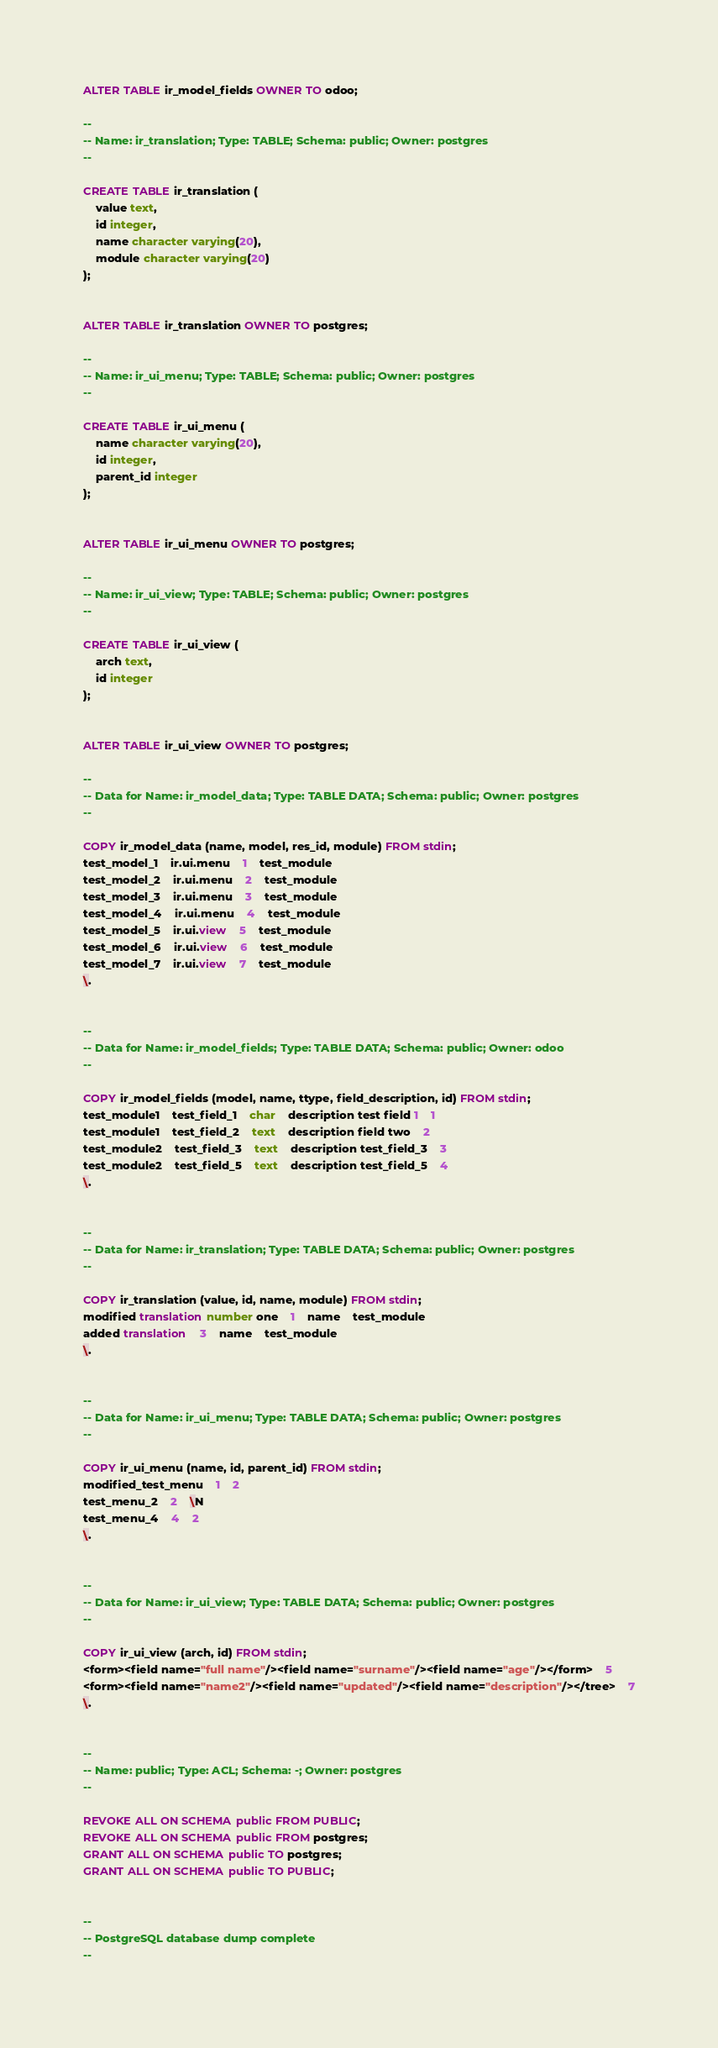Convert code to text. <code><loc_0><loc_0><loc_500><loc_500><_SQL_>
ALTER TABLE ir_model_fields OWNER TO odoo;

--
-- Name: ir_translation; Type: TABLE; Schema: public; Owner: postgres
--

CREATE TABLE ir_translation (
    value text,
    id integer,
    name character varying(20),
    module character varying(20)
);


ALTER TABLE ir_translation OWNER TO postgres;

--
-- Name: ir_ui_menu; Type: TABLE; Schema: public; Owner: postgres
--

CREATE TABLE ir_ui_menu (
    name character varying(20),
    id integer,
    parent_id integer
);


ALTER TABLE ir_ui_menu OWNER TO postgres;

--
-- Name: ir_ui_view; Type: TABLE; Schema: public; Owner: postgres
--

CREATE TABLE ir_ui_view (
    arch text,
    id integer
);


ALTER TABLE ir_ui_view OWNER TO postgres;

--
-- Data for Name: ir_model_data; Type: TABLE DATA; Schema: public; Owner: postgres
--

COPY ir_model_data (name, model, res_id, module) FROM stdin;
test_model_1	ir.ui.menu	1	test_module
test_model_2	ir.ui.menu	2	test_module
test_model_3	ir.ui.menu	3	test_module
test_model_4	ir.ui.menu	4	test_module
test_model_5	ir.ui.view	5	test_module
test_model_6	ir.ui.view	6	test_module
test_model_7	ir.ui.view	7	test_module
\.


--
-- Data for Name: ir_model_fields; Type: TABLE DATA; Schema: public; Owner: odoo
--

COPY ir_model_fields (model, name, ttype, field_description, id) FROM stdin;
test_module1	test_field_1	char	description test field 1	1
test_module1	test_field_2	text	description field two	2
test_module2	test_field_3	text	description test_field_3	3
test_module2	test_field_5	text	description test_field_5	4
\.


--
-- Data for Name: ir_translation; Type: TABLE DATA; Schema: public; Owner: postgres
--

COPY ir_translation (value, id, name, module) FROM stdin;
modified translation number one	1	name	test_module
added translation	3	name	test_module
\.


--
-- Data for Name: ir_ui_menu; Type: TABLE DATA; Schema: public; Owner: postgres
--

COPY ir_ui_menu (name, id, parent_id) FROM stdin;
modified_test_menu	1	2
test_menu_2	2	\N
test_menu_4	4	2
\.


--
-- Data for Name: ir_ui_view; Type: TABLE DATA; Schema: public; Owner: postgres
--

COPY ir_ui_view (arch, id) FROM stdin;
<form><field name="full name"/><field name="surname"/><field name="age"/></form>	5
<form><field name="name2"/><field name="updated"/><field name="description"/></tree>	7
\.


--
-- Name: public; Type: ACL; Schema: -; Owner: postgres
--

REVOKE ALL ON SCHEMA public FROM PUBLIC;
REVOKE ALL ON SCHEMA public FROM postgres;
GRANT ALL ON SCHEMA public TO postgres;
GRANT ALL ON SCHEMA public TO PUBLIC;


--
-- PostgreSQL database dump complete
--

</code> 